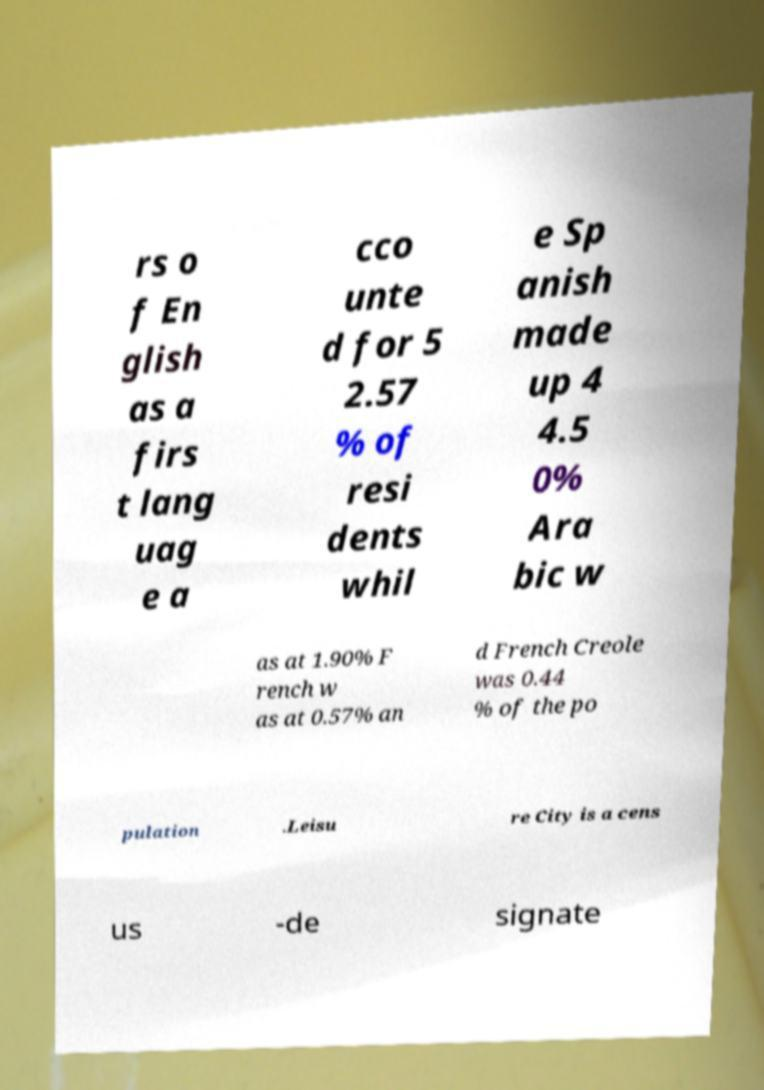There's text embedded in this image that I need extracted. Can you transcribe it verbatim? rs o f En glish as a firs t lang uag e a cco unte d for 5 2.57 % of resi dents whil e Sp anish made up 4 4.5 0% Ara bic w as at 1.90% F rench w as at 0.57% an d French Creole was 0.44 % of the po pulation .Leisu re City is a cens us -de signate 